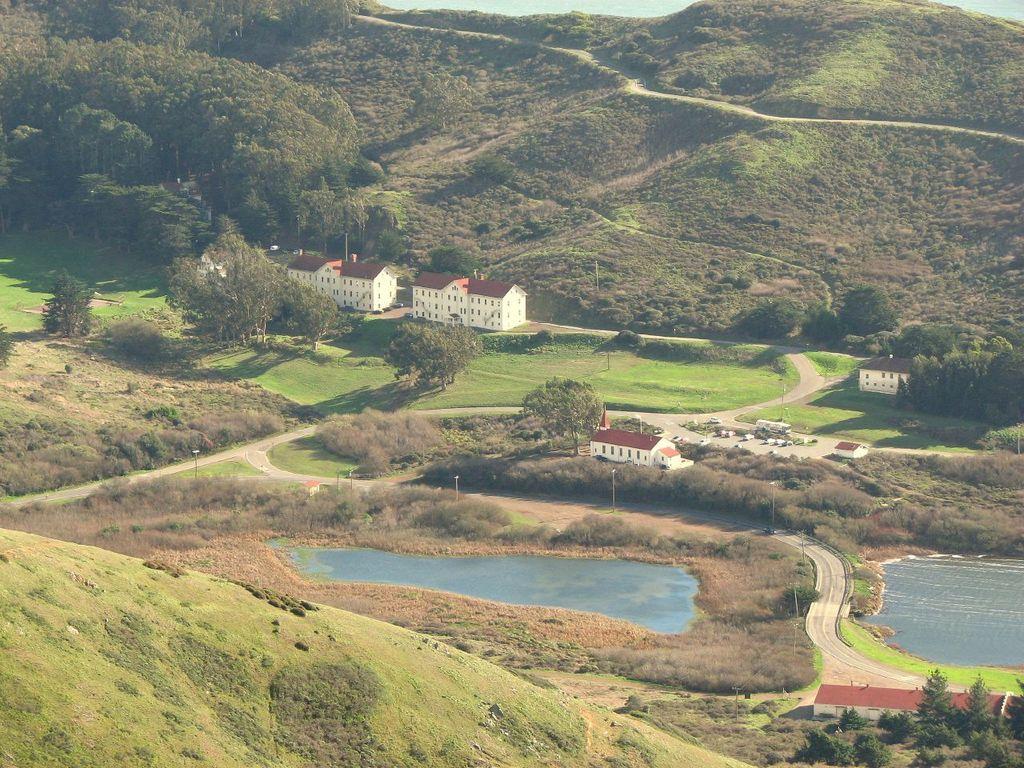Describe this image in one or two sentences. In this image, in the middle there are trees, houses, water, lakes, road, grass, hills. 